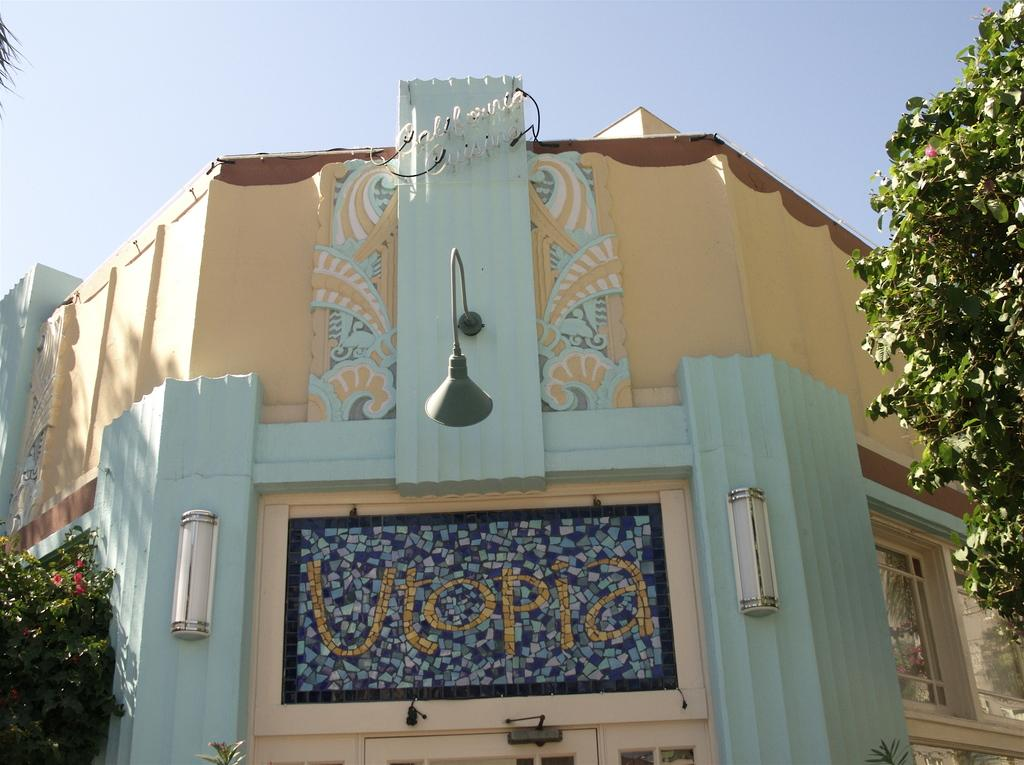What type of vegetation is present on both sides of the image? There are trees on either side of the image. What structure is located in the middle of the image? There is a board on a building in the middle of the image. What is visible at the top of the image? The sky is visible at the top of the image. Is there any quicksand present in the image? No, there is no quicksand present in the image. What type of emotion is being expressed by the trees in the image? Trees do not express emotions, so this question cannot be answered. 